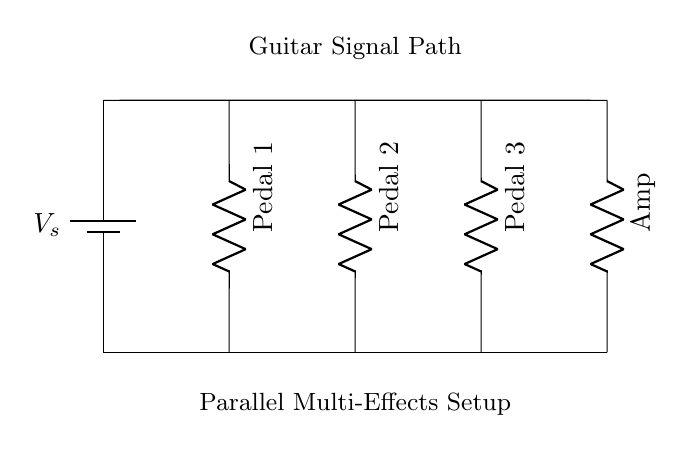What is the total number of pedals in this setup? There are three pedals shown in the diagram, which are labeled as Pedal 1, Pedal 2, and Pedal 3.
Answer: 3 What is the component used for the amplification in this circuit? The component labeled as "Amp" is used for amplification, positioned after the pedals in the signal path.
Answer: Amp What type of circuit is represented here? This circuit is a parallel configuration since each pedal connection runs alongside the others to the main signal path.
Answer: Parallel How does the power supply connect to the pedals? The power supply connects to the main line which distributes voltage to each pedal simultaneously, indicating they all receive the same voltage supply.
Answer: Main line What happens to the signal if one pedal is turned off? The signal will continue to flow through the other active pedals, as they are arranged in parallel, allowing for independent operation.
Answer: Continues to flow What is the purpose of using a parallel circuit for the effects pedals? A parallel circuit allows the guitar signal to be processed by multiple effects simultaneously without affecting each other's signals, preserving tone and effect integrity.
Answer: Simultaneous processing 